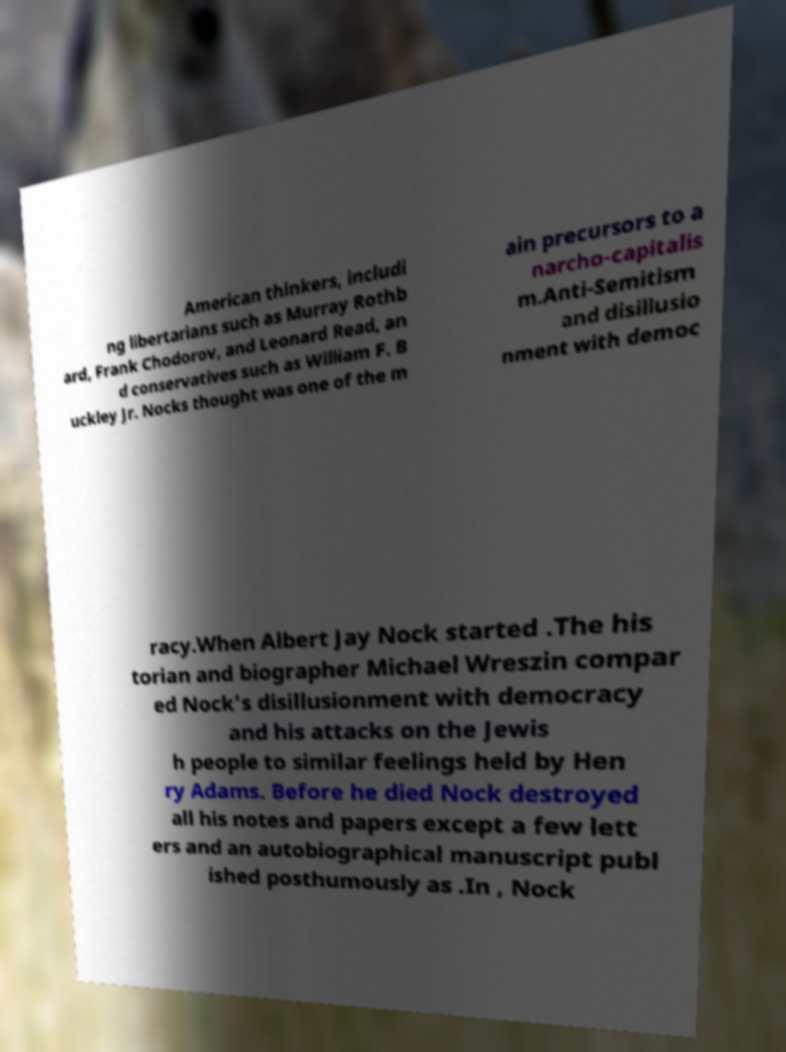For documentation purposes, I need the text within this image transcribed. Could you provide that? American thinkers, includi ng libertarians such as Murray Rothb ard, Frank Chodorov, and Leonard Read, an d conservatives such as William F. B uckley Jr. Nocks thought was one of the m ain precursors to a narcho-capitalis m.Anti-Semitism and disillusio nment with democ racy.When Albert Jay Nock started .The his torian and biographer Michael Wreszin compar ed Nock's disillusionment with democracy and his attacks on the Jewis h people to similar feelings held by Hen ry Adams. Before he died Nock destroyed all his notes and papers except a few lett ers and an autobiographical manuscript publ ished posthumously as .In , Nock 